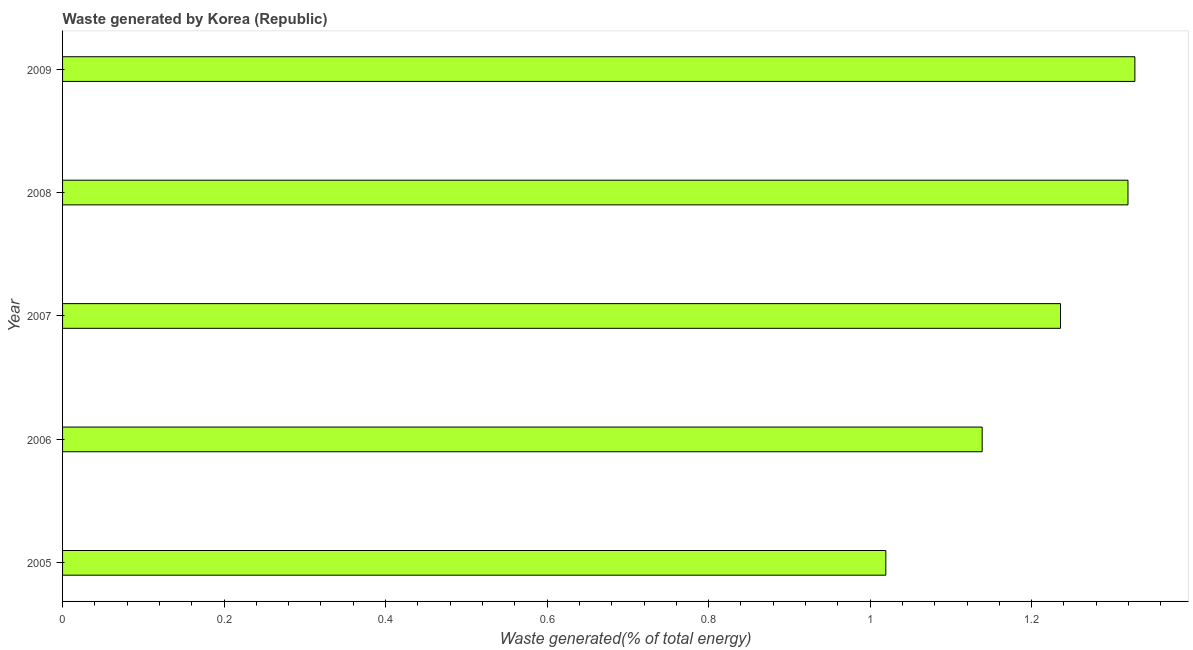Does the graph contain grids?
Make the answer very short. No. What is the title of the graph?
Provide a short and direct response. Waste generated by Korea (Republic). What is the label or title of the X-axis?
Your answer should be very brief. Waste generated(% of total energy). What is the amount of waste generated in 2009?
Keep it short and to the point. 1.33. Across all years, what is the maximum amount of waste generated?
Provide a short and direct response. 1.33. Across all years, what is the minimum amount of waste generated?
Provide a short and direct response. 1.02. What is the sum of the amount of waste generated?
Your answer should be very brief. 6.04. What is the difference between the amount of waste generated in 2007 and 2009?
Ensure brevity in your answer.  -0.09. What is the average amount of waste generated per year?
Your response must be concise. 1.21. What is the median amount of waste generated?
Provide a succinct answer. 1.24. In how many years, is the amount of waste generated greater than 1.16 %?
Give a very brief answer. 3. Do a majority of the years between 2006 and 2007 (inclusive) have amount of waste generated greater than 0.44 %?
Your answer should be compact. Yes. What is the ratio of the amount of waste generated in 2006 to that in 2008?
Your answer should be compact. 0.86. Is the difference between the amount of waste generated in 2007 and 2009 greater than the difference between any two years?
Your answer should be very brief. No. What is the difference between the highest and the second highest amount of waste generated?
Make the answer very short. 0.01. Is the sum of the amount of waste generated in 2007 and 2009 greater than the maximum amount of waste generated across all years?
Your answer should be compact. Yes. What is the difference between the highest and the lowest amount of waste generated?
Your answer should be very brief. 0.31. In how many years, is the amount of waste generated greater than the average amount of waste generated taken over all years?
Make the answer very short. 3. Are the values on the major ticks of X-axis written in scientific E-notation?
Give a very brief answer. No. What is the Waste generated(% of total energy) in 2005?
Your answer should be compact. 1.02. What is the Waste generated(% of total energy) of 2006?
Provide a short and direct response. 1.14. What is the Waste generated(% of total energy) in 2007?
Your answer should be very brief. 1.24. What is the Waste generated(% of total energy) in 2008?
Keep it short and to the point. 1.32. What is the Waste generated(% of total energy) of 2009?
Offer a very short reply. 1.33. What is the difference between the Waste generated(% of total energy) in 2005 and 2006?
Your answer should be very brief. -0.12. What is the difference between the Waste generated(% of total energy) in 2005 and 2007?
Offer a terse response. -0.22. What is the difference between the Waste generated(% of total energy) in 2005 and 2008?
Give a very brief answer. -0.3. What is the difference between the Waste generated(% of total energy) in 2005 and 2009?
Your answer should be compact. -0.31. What is the difference between the Waste generated(% of total energy) in 2006 and 2007?
Your response must be concise. -0.1. What is the difference between the Waste generated(% of total energy) in 2006 and 2008?
Offer a terse response. -0.18. What is the difference between the Waste generated(% of total energy) in 2006 and 2009?
Make the answer very short. -0.19. What is the difference between the Waste generated(% of total energy) in 2007 and 2008?
Provide a succinct answer. -0.08. What is the difference between the Waste generated(% of total energy) in 2007 and 2009?
Offer a very short reply. -0.09. What is the difference between the Waste generated(% of total energy) in 2008 and 2009?
Keep it short and to the point. -0.01. What is the ratio of the Waste generated(% of total energy) in 2005 to that in 2006?
Ensure brevity in your answer.  0.9. What is the ratio of the Waste generated(% of total energy) in 2005 to that in 2007?
Keep it short and to the point. 0.82. What is the ratio of the Waste generated(% of total energy) in 2005 to that in 2008?
Your response must be concise. 0.77. What is the ratio of the Waste generated(% of total energy) in 2005 to that in 2009?
Your answer should be compact. 0.77. What is the ratio of the Waste generated(% of total energy) in 2006 to that in 2007?
Give a very brief answer. 0.92. What is the ratio of the Waste generated(% of total energy) in 2006 to that in 2008?
Provide a short and direct response. 0.86. What is the ratio of the Waste generated(% of total energy) in 2006 to that in 2009?
Offer a very short reply. 0.86. What is the ratio of the Waste generated(% of total energy) in 2007 to that in 2008?
Ensure brevity in your answer.  0.94. What is the ratio of the Waste generated(% of total energy) in 2007 to that in 2009?
Your answer should be compact. 0.93. 